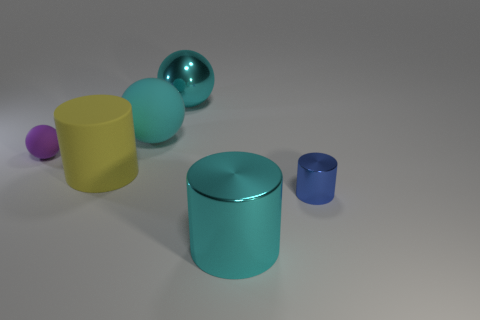Add 4 tiny rubber balls. How many objects exist? 10 Add 5 tiny metal balls. How many tiny metal balls exist? 5 Subtract 0 brown balls. How many objects are left? 6 Subtract all big cyan cylinders. Subtract all tiny blue metallic cylinders. How many objects are left? 4 Add 3 large rubber cylinders. How many large rubber cylinders are left? 4 